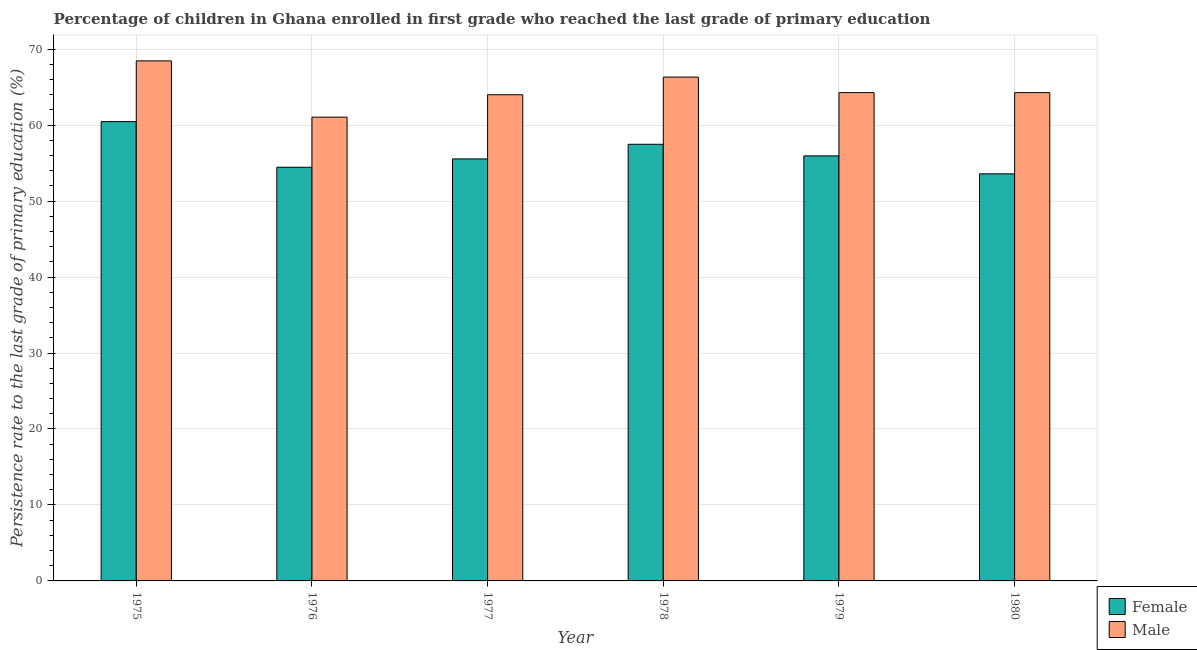How many groups of bars are there?
Your answer should be compact. 6. Are the number of bars per tick equal to the number of legend labels?
Provide a succinct answer. Yes. How many bars are there on the 1st tick from the left?
Keep it short and to the point. 2. How many bars are there on the 6th tick from the right?
Provide a succinct answer. 2. What is the label of the 2nd group of bars from the left?
Provide a succinct answer. 1976. In how many cases, is the number of bars for a given year not equal to the number of legend labels?
Provide a succinct answer. 0. What is the persistence rate of female students in 1979?
Keep it short and to the point. 55.95. Across all years, what is the maximum persistence rate of female students?
Your response must be concise. 60.47. Across all years, what is the minimum persistence rate of male students?
Provide a succinct answer. 61.06. In which year was the persistence rate of female students maximum?
Offer a very short reply. 1975. In which year was the persistence rate of female students minimum?
Provide a short and direct response. 1980. What is the total persistence rate of male students in the graph?
Provide a succinct answer. 388.4. What is the difference between the persistence rate of male students in 1976 and that in 1978?
Make the answer very short. -5.27. What is the difference between the persistence rate of female students in 1978 and the persistence rate of male students in 1977?
Your response must be concise. 1.93. What is the average persistence rate of female students per year?
Provide a short and direct response. 56.25. In the year 1980, what is the difference between the persistence rate of female students and persistence rate of male students?
Give a very brief answer. 0. In how many years, is the persistence rate of male students greater than 52 %?
Give a very brief answer. 6. What is the ratio of the persistence rate of female students in 1979 to that in 1980?
Offer a terse response. 1.04. Is the difference between the persistence rate of male students in 1975 and 1977 greater than the difference between the persistence rate of female students in 1975 and 1977?
Offer a terse response. No. What is the difference between the highest and the second highest persistence rate of female students?
Your answer should be very brief. 2.99. What is the difference between the highest and the lowest persistence rate of female students?
Your answer should be very brief. 6.88. Is the sum of the persistence rate of female students in 1978 and 1980 greater than the maximum persistence rate of male students across all years?
Offer a terse response. Yes. Are all the bars in the graph horizontal?
Give a very brief answer. No. Are the values on the major ticks of Y-axis written in scientific E-notation?
Keep it short and to the point. No. How many legend labels are there?
Offer a very short reply. 2. What is the title of the graph?
Keep it short and to the point. Percentage of children in Ghana enrolled in first grade who reached the last grade of primary education. Does "US$" appear as one of the legend labels in the graph?
Your response must be concise. No. What is the label or title of the X-axis?
Your answer should be compact. Year. What is the label or title of the Y-axis?
Your answer should be compact. Persistence rate to the last grade of primary education (%). What is the Persistence rate to the last grade of primary education (%) of Female in 1975?
Your response must be concise. 60.47. What is the Persistence rate to the last grade of primary education (%) in Male in 1975?
Give a very brief answer. 68.46. What is the Persistence rate to the last grade of primary education (%) in Female in 1976?
Give a very brief answer. 54.46. What is the Persistence rate to the last grade of primary education (%) in Male in 1976?
Give a very brief answer. 61.06. What is the Persistence rate to the last grade of primary education (%) in Female in 1977?
Provide a short and direct response. 55.55. What is the Persistence rate to the last grade of primary education (%) in Male in 1977?
Give a very brief answer. 64. What is the Persistence rate to the last grade of primary education (%) in Female in 1978?
Make the answer very short. 57.48. What is the Persistence rate to the last grade of primary education (%) in Male in 1978?
Your answer should be very brief. 66.33. What is the Persistence rate to the last grade of primary education (%) in Female in 1979?
Provide a succinct answer. 55.95. What is the Persistence rate to the last grade of primary education (%) of Male in 1979?
Offer a very short reply. 64.28. What is the Persistence rate to the last grade of primary education (%) of Female in 1980?
Provide a succinct answer. 53.59. What is the Persistence rate to the last grade of primary education (%) in Male in 1980?
Your answer should be very brief. 64.28. Across all years, what is the maximum Persistence rate to the last grade of primary education (%) of Female?
Your response must be concise. 60.47. Across all years, what is the maximum Persistence rate to the last grade of primary education (%) of Male?
Ensure brevity in your answer.  68.46. Across all years, what is the minimum Persistence rate to the last grade of primary education (%) in Female?
Make the answer very short. 53.59. Across all years, what is the minimum Persistence rate to the last grade of primary education (%) in Male?
Ensure brevity in your answer.  61.06. What is the total Persistence rate to the last grade of primary education (%) in Female in the graph?
Make the answer very short. 337.5. What is the total Persistence rate to the last grade of primary education (%) of Male in the graph?
Give a very brief answer. 388.4. What is the difference between the Persistence rate to the last grade of primary education (%) in Female in 1975 and that in 1976?
Offer a very short reply. 6.01. What is the difference between the Persistence rate to the last grade of primary education (%) of Male in 1975 and that in 1976?
Provide a short and direct response. 7.41. What is the difference between the Persistence rate to the last grade of primary education (%) in Female in 1975 and that in 1977?
Offer a very short reply. 4.91. What is the difference between the Persistence rate to the last grade of primary education (%) of Male in 1975 and that in 1977?
Offer a very short reply. 4.46. What is the difference between the Persistence rate to the last grade of primary education (%) of Female in 1975 and that in 1978?
Offer a very short reply. 2.99. What is the difference between the Persistence rate to the last grade of primary education (%) in Male in 1975 and that in 1978?
Your answer should be very brief. 2.14. What is the difference between the Persistence rate to the last grade of primary education (%) of Female in 1975 and that in 1979?
Offer a terse response. 4.51. What is the difference between the Persistence rate to the last grade of primary education (%) of Male in 1975 and that in 1979?
Your answer should be very brief. 4.18. What is the difference between the Persistence rate to the last grade of primary education (%) of Female in 1975 and that in 1980?
Provide a short and direct response. 6.88. What is the difference between the Persistence rate to the last grade of primary education (%) of Male in 1975 and that in 1980?
Provide a short and direct response. 4.18. What is the difference between the Persistence rate to the last grade of primary education (%) of Female in 1976 and that in 1977?
Offer a terse response. -1.1. What is the difference between the Persistence rate to the last grade of primary education (%) of Male in 1976 and that in 1977?
Provide a short and direct response. -2.95. What is the difference between the Persistence rate to the last grade of primary education (%) in Female in 1976 and that in 1978?
Your answer should be compact. -3.02. What is the difference between the Persistence rate to the last grade of primary education (%) of Male in 1976 and that in 1978?
Offer a very short reply. -5.27. What is the difference between the Persistence rate to the last grade of primary education (%) of Female in 1976 and that in 1979?
Provide a short and direct response. -1.5. What is the difference between the Persistence rate to the last grade of primary education (%) of Male in 1976 and that in 1979?
Give a very brief answer. -3.22. What is the difference between the Persistence rate to the last grade of primary education (%) in Female in 1976 and that in 1980?
Your response must be concise. 0.87. What is the difference between the Persistence rate to the last grade of primary education (%) of Male in 1976 and that in 1980?
Your answer should be very brief. -3.22. What is the difference between the Persistence rate to the last grade of primary education (%) of Female in 1977 and that in 1978?
Provide a succinct answer. -1.93. What is the difference between the Persistence rate to the last grade of primary education (%) of Male in 1977 and that in 1978?
Ensure brevity in your answer.  -2.32. What is the difference between the Persistence rate to the last grade of primary education (%) of Male in 1977 and that in 1979?
Make the answer very short. -0.28. What is the difference between the Persistence rate to the last grade of primary education (%) of Female in 1977 and that in 1980?
Keep it short and to the point. 1.96. What is the difference between the Persistence rate to the last grade of primary education (%) of Male in 1977 and that in 1980?
Provide a short and direct response. -0.28. What is the difference between the Persistence rate to the last grade of primary education (%) in Female in 1978 and that in 1979?
Keep it short and to the point. 1.53. What is the difference between the Persistence rate to the last grade of primary education (%) of Male in 1978 and that in 1979?
Offer a terse response. 2.05. What is the difference between the Persistence rate to the last grade of primary education (%) in Female in 1978 and that in 1980?
Ensure brevity in your answer.  3.89. What is the difference between the Persistence rate to the last grade of primary education (%) in Male in 1978 and that in 1980?
Make the answer very short. 2.05. What is the difference between the Persistence rate to the last grade of primary education (%) of Female in 1979 and that in 1980?
Ensure brevity in your answer.  2.36. What is the difference between the Persistence rate to the last grade of primary education (%) in Male in 1979 and that in 1980?
Provide a short and direct response. 0. What is the difference between the Persistence rate to the last grade of primary education (%) of Female in 1975 and the Persistence rate to the last grade of primary education (%) of Male in 1976?
Your answer should be very brief. -0.59. What is the difference between the Persistence rate to the last grade of primary education (%) of Female in 1975 and the Persistence rate to the last grade of primary education (%) of Male in 1977?
Provide a succinct answer. -3.54. What is the difference between the Persistence rate to the last grade of primary education (%) of Female in 1975 and the Persistence rate to the last grade of primary education (%) of Male in 1978?
Provide a short and direct response. -5.86. What is the difference between the Persistence rate to the last grade of primary education (%) of Female in 1975 and the Persistence rate to the last grade of primary education (%) of Male in 1979?
Your response must be concise. -3.81. What is the difference between the Persistence rate to the last grade of primary education (%) of Female in 1975 and the Persistence rate to the last grade of primary education (%) of Male in 1980?
Your answer should be very brief. -3.81. What is the difference between the Persistence rate to the last grade of primary education (%) of Female in 1976 and the Persistence rate to the last grade of primary education (%) of Male in 1977?
Keep it short and to the point. -9.55. What is the difference between the Persistence rate to the last grade of primary education (%) in Female in 1976 and the Persistence rate to the last grade of primary education (%) in Male in 1978?
Your answer should be very brief. -11.87. What is the difference between the Persistence rate to the last grade of primary education (%) in Female in 1976 and the Persistence rate to the last grade of primary education (%) in Male in 1979?
Provide a short and direct response. -9.82. What is the difference between the Persistence rate to the last grade of primary education (%) of Female in 1976 and the Persistence rate to the last grade of primary education (%) of Male in 1980?
Make the answer very short. -9.82. What is the difference between the Persistence rate to the last grade of primary education (%) in Female in 1977 and the Persistence rate to the last grade of primary education (%) in Male in 1978?
Provide a short and direct response. -10.77. What is the difference between the Persistence rate to the last grade of primary education (%) in Female in 1977 and the Persistence rate to the last grade of primary education (%) in Male in 1979?
Offer a terse response. -8.73. What is the difference between the Persistence rate to the last grade of primary education (%) of Female in 1977 and the Persistence rate to the last grade of primary education (%) of Male in 1980?
Make the answer very short. -8.73. What is the difference between the Persistence rate to the last grade of primary education (%) of Female in 1978 and the Persistence rate to the last grade of primary education (%) of Male in 1980?
Provide a succinct answer. -6.8. What is the difference between the Persistence rate to the last grade of primary education (%) in Female in 1979 and the Persistence rate to the last grade of primary education (%) in Male in 1980?
Keep it short and to the point. -8.33. What is the average Persistence rate to the last grade of primary education (%) of Female per year?
Keep it short and to the point. 56.25. What is the average Persistence rate to the last grade of primary education (%) in Male per year?
Keep it short and to the point. 64.73. In the year 1975, what is the difference between the Persistence rate to the last grade of primary education (%) of Female and Persistence rate to the last grade of primary education (%) of Male?
Give a very brief answer. -7.99. In the year 1976, what is the difference between the Persistence rate to the last grade of primary education (%) of Female and Persistence rate to the last grade of primary education (%) of Male?
Your response must be concise. -6.6. In the year 1977, what is the difference between the Persistence rate to the last grade of primary education (%) in Female and Persistence rate to the last grade of primary education (%) in Male?
Your response must be concise. -8.45. In the year 1978, what is the difference between the Persistence rate to the last grade of primary education (%) of Female and Persistence rate to the last grade of primary education (%) of Male?
Provide a succinct answer. -8.85. In the year 1979, what is the difference between the Persistence rate to the last grade of primary education (%) of Female and Persistence rate to the last grade of primary education (%) of Male?
Give a very brief answer. -8.33. In the year 1980, what is the difference between the Persistence rate to the last grade of primary education (%) of Female and Persistence rate to the last grade of primary education (%) of Male?
Make the answer very short. -10.69. What is the ratio of the Persistence rate to the last grade of primary education (%) of Female in 1975 to that in 1976?
Provide a succinct answer. 1.11. What is the ratio of the Persistence rate to the last grade of primary education (%) in Male in 1975 to that in 1976?
Keep it short and to the point. 1.12. What is the ratio of the Persistence rate to the last grade of primary education (%) of Female in 1975 to that in 1977?
Provide a succinct answer. 1.09. What is the ratio of the Persistence rate to the last grade of primary education (%) in Male in 1975 to that in 1977?
Make the answer very short. 1.07. What is the ratio of the Persistence rate to the last grade of primary education (%) in Female in 1975 to that in 1978?
Your response must be concise. 1.05. What is the ratio of the Persistence rate to the last grade of primary education (%) of Male in 1975 to that in 1978?
Offer a very short reply. 1.03. What is the ratio of the Persistence rate to the last grade of primary education (%) in Female in 1975 to that in 1979?
Keep it short and to the point. 1.08. What is the ratio of the Persistence rate to the last grade of primary education (%) of Male in 1975 to that in 1979?
Provide a short and direct response. 1.06. What is the ratio of the Persistence rate to the last grade of primary education (%) in Female in 1975 to that in 1980?
Make the answer very short. 1.13. What is the ratio of the Persistence rate to the last grade of primary education (%) in Male in 1975 to that in 1980?
Provide a short and direct response. 1.07. What is the ratio of the Persistence rate to the last grade of primary education (%) in Female in 1976 to that in 1977?
Your response must be concise. 0.98. What is the ratio of the Persistence rate to the last grade of primary education (%) in Male in 1976 to that in 1977?
Provide a succinct answer. 0.95. What is the ratio of the Persistence rate to the last grade of primary education (%) in Female in 1976 to that in 1978?
Your answer should be very brief. 0.95. What is the ratio of the Persistence rate to the last grade of primary education (%) of Male in 1976 to that in 1978?
Provide a succinct answer. 0.92. What is the ratio of the Persistence rate to the last grade of primary education (%) of Female in 1976 to that in 1979?
Give a very brief answer. 0.97. What is the ratio of the Persistence rate to the last grade of primary education (%) in Male in 1976 to that in 1979?
Provide a short and direct response. 0.95. What is the ratio of the Persistence rate to the last grade of primary education (%) in Female in 1976 to that in 1980?
Ensure brevity in your answer.  1.02. What is the ratio of the Persistence rate to the last grade of primary education (%) in Male in 1976 to that in 1980?
Keep it short and to the point. 0.95. What is the ratio of the Persistence rate to the last grade of primary education (%) of Female in 1977 to that in 1978?
Offer a very short reply. 0.97. What is the ratio of the Persistence rate to the last grade of primary education (%) in Male in 1977 to that in 1978?
Ensure brevity in your answer.  0.96. What is the ratio of the Persistence rate to the last grade of primary education (%) of Male in 1977 to that in 1979?
Offer a terse response. 1. What is the ratio of the Persistence rate to the last grade of primary education (%) in Female in 1977 to that in 1980?
Your answer should be very brief. 1.04. What is the ratio of the Persistence rate to the last grade of primary education (%) in Male in 1977 to that in 1980?
Your response must be concise. 1. What is the ratio of the Persistence rate to the last grade of primary education (%) in Female in 1978 to that in 1979?
Your response must be concise. 1.03. What is the ratio of the Persistence rate to the last grade of primary education (%) in Male in 1978 to that in 1979?
Provide a succinct answer. 1.03. What is the ratio of the Persistence rate to the last grade of primary education (%) of Female in 1978 to that in 1980?
Provide a short and direct response. 1.07. What is the ratio of the Persistence rate to the last grade of primary education (%) of Male in 1978 to that in 1980?
Your answer should be very brief. 1.03. What is the ratio of the Persistence rate to the last grade of primary education (%) of Female in 1979 to that in 1980?
Your answer should be very brief. 1.04. What is the difference between the highest and the second highest Persistence rate to the last grade of primary education (%) in Female?
Your answer should be compact. 2.99. What is the difference between the highest and the second highest Persistence rate to the last grade of primary education (%) in Male?
Give a very brief answer. 2.14. What is the difference between the highest and the lowest Persistence rate to the last grade of primary education (%) in Female?
Provide a short and direct response. 6.88. What is the difference between the highest and the lowest Persistence rate to the last grade of primary education (%) in Male?
Your response must be concise. 7.41. 